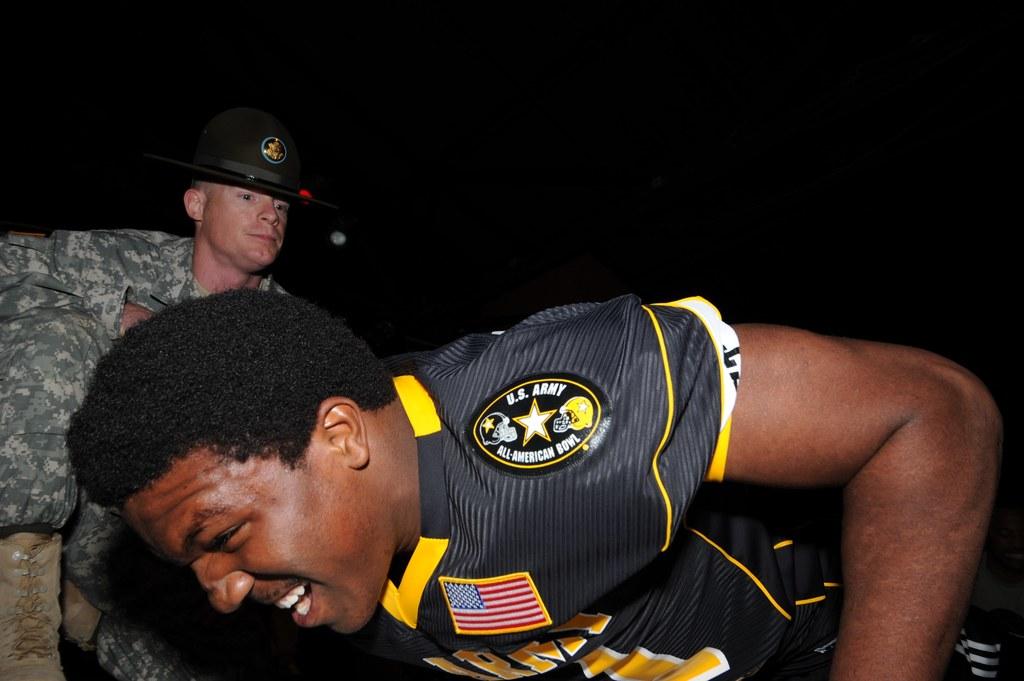What military outfit patch is shown?
Keep it short and to the point. U.s. army. 